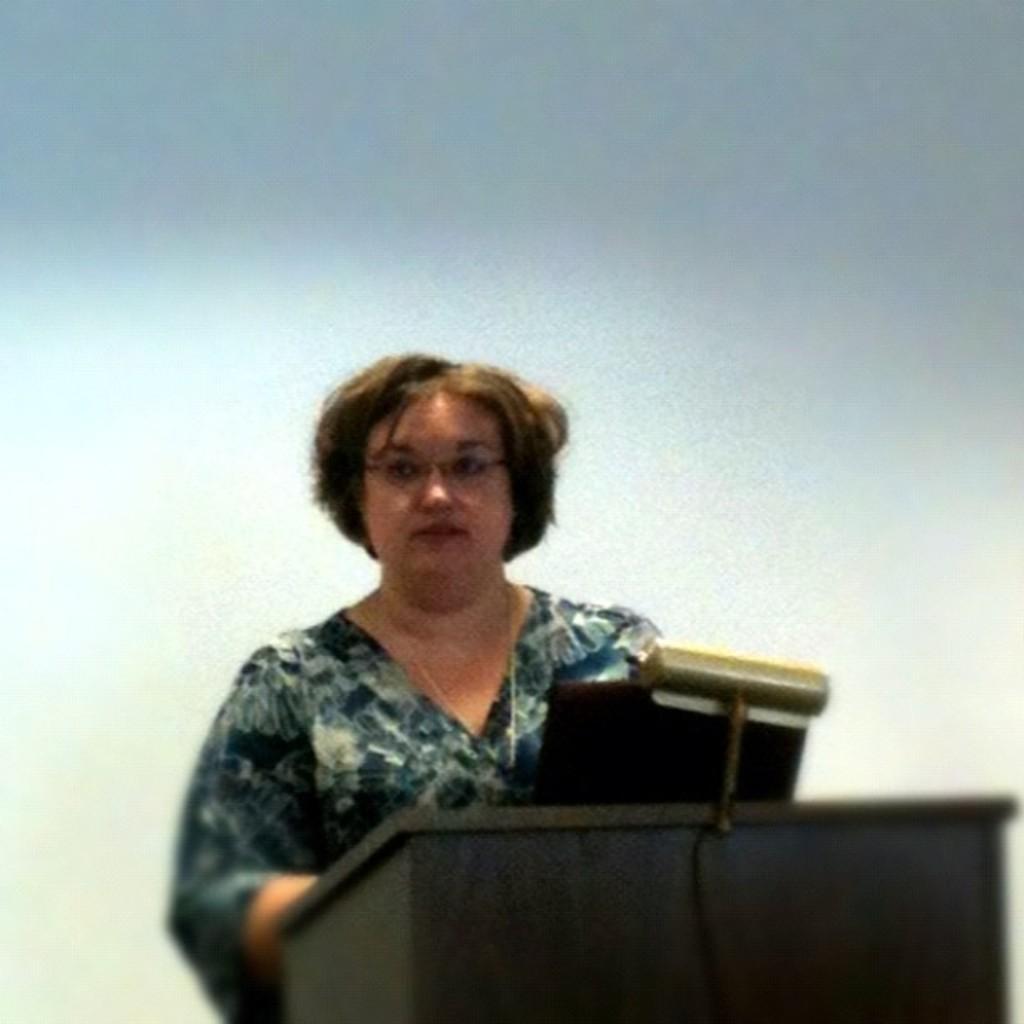How would you summarize this image in a sentence or two? In this picture, it looks like a podium and on the podium there is a laptop. A woman is standing behind the podium and behind the woman there is the blurred background. 